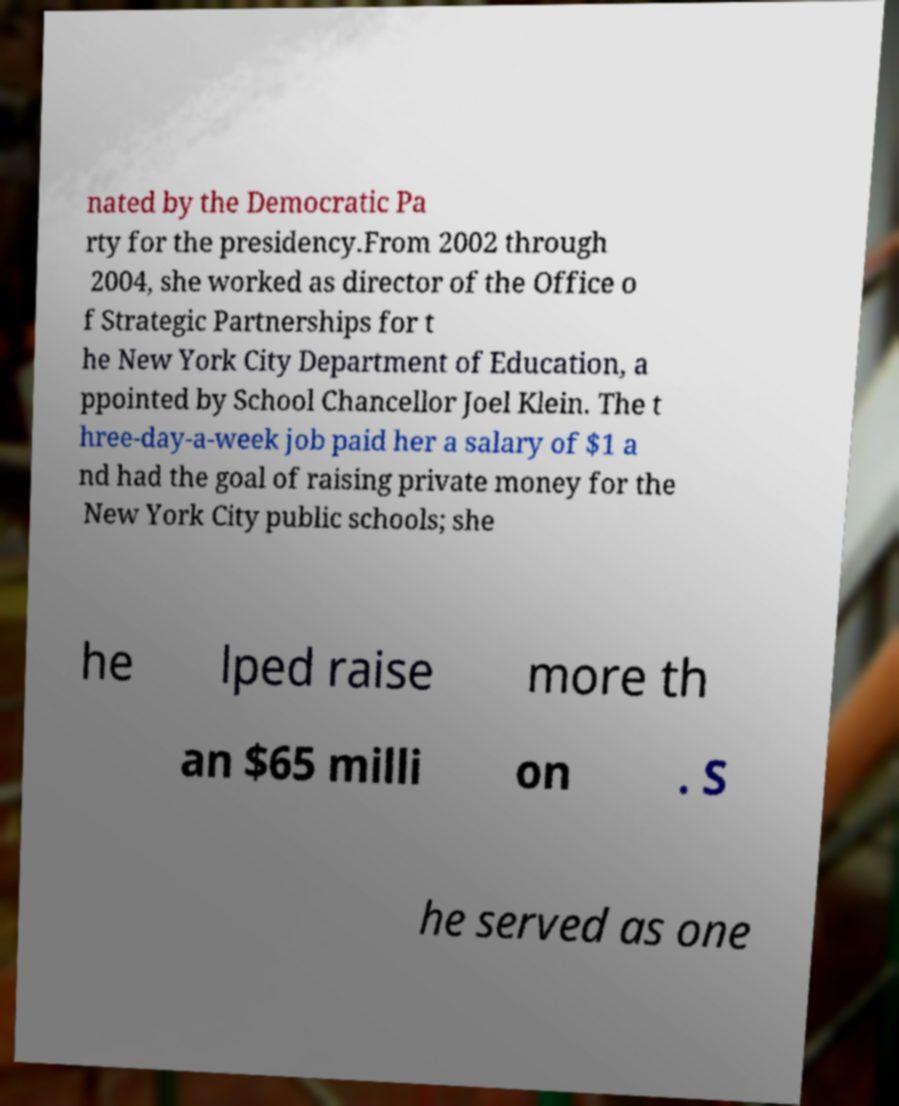Can you accurately transcribe the text from the provided image for me? nated by the Democratic Pa rty for the presidency.From 2002 through 2004, she worked as director of the Office o f Strategic Partnerships for t he New York City Department of Education, a ppointed by School Chancellor Joel Klein. The t hree-day-a-week job paid her a salary of $1 a nd had the goal of raising private money for the New York City public schools; she he lped raise more th an $65 milli on . S he served as one 